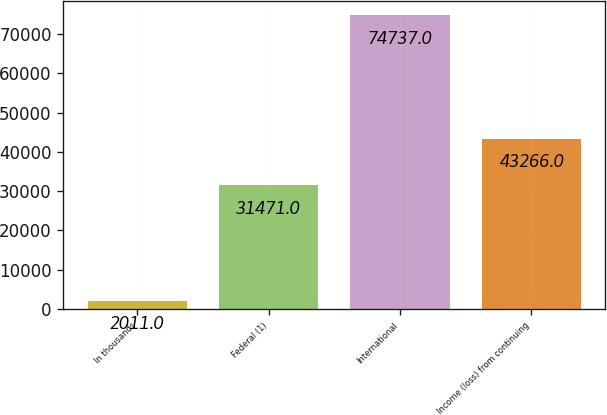Convert chart to OTSL. <chart><loc_0><loc_0><loc_500><loc_500><bar_chart><fcel>In thousands<fcel>Federal (1)<fcel>International<fcel>Income (loss) from continuing<nl><fcel>2011<fcel>31471<fcel>74737<fcel>43266<nl></chart> 